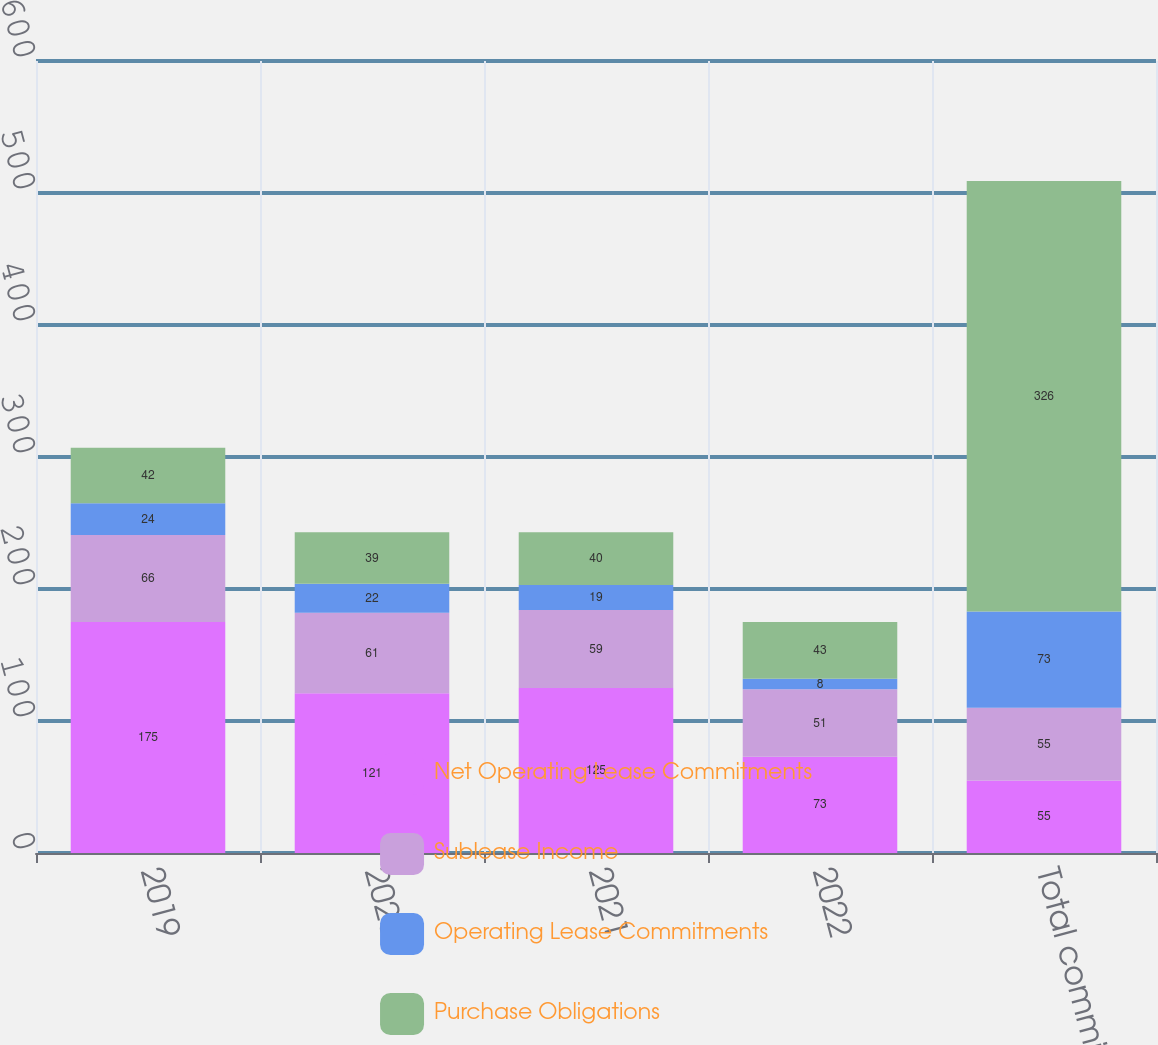Convert chart to OTSL. <chart><loc_0><loc_0><loc_500><loc_500><stacked_bar_chart><ecel><fcel>2019<fcel>2020<fcel>2021<fcel>2022<fcel>Total commitments<nl><fcel>Net Operating Lease Commitments<fcel>175<fcel>121<fcel>125<fcel>73<fcel>55<nl><fcel>Sublease Income<fcel>66<fcel>61<fcel>59<fcel>51<fcel>55<nl><fcel>Operating Lease Commitments<fcel>24<fcel>22<fcel>19<fcel>8<fcel>73<nl><fcel>Purchase Obligations<fcel>42<fcel>39<fcel>40<fcel>43<fcel>326<nl></chart> 